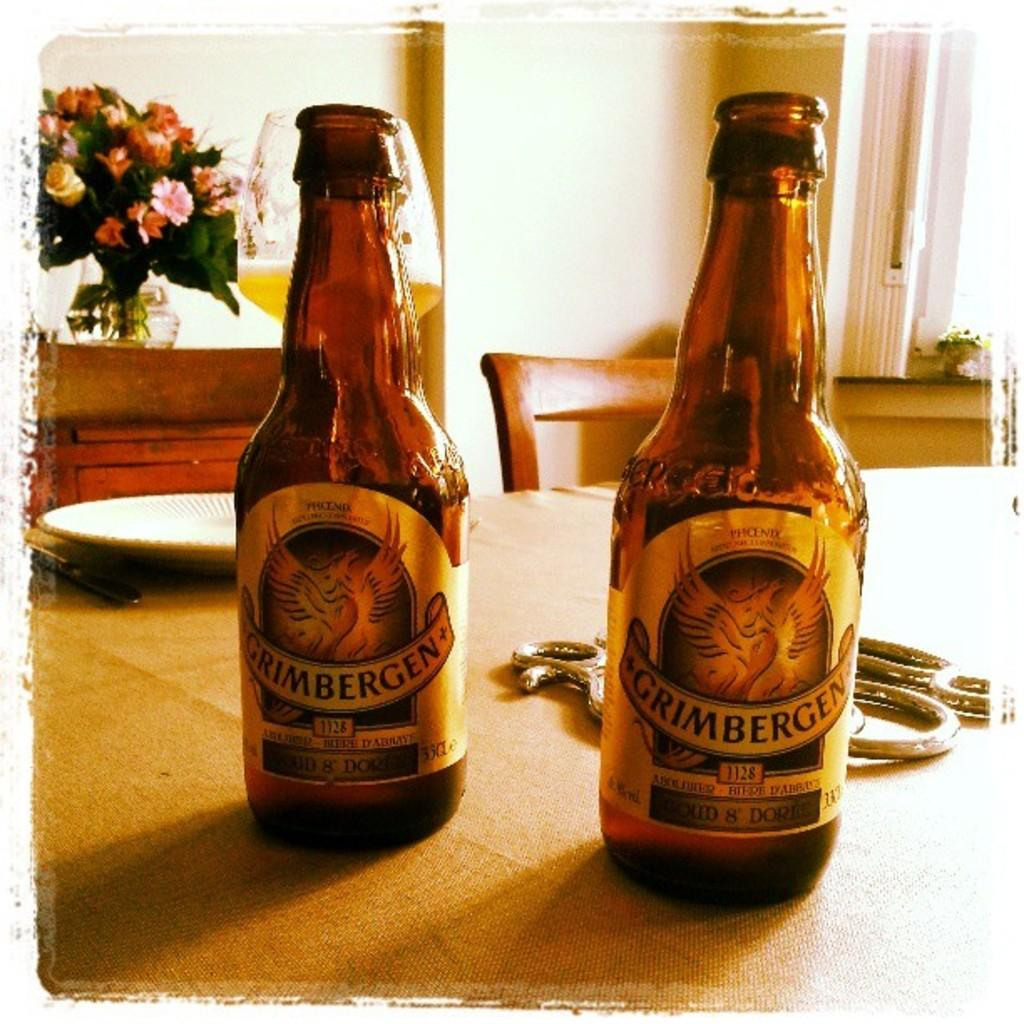<image>
Provide a brief description of the given image. Two Grimbergen bottles of beer on a kitchen table. 